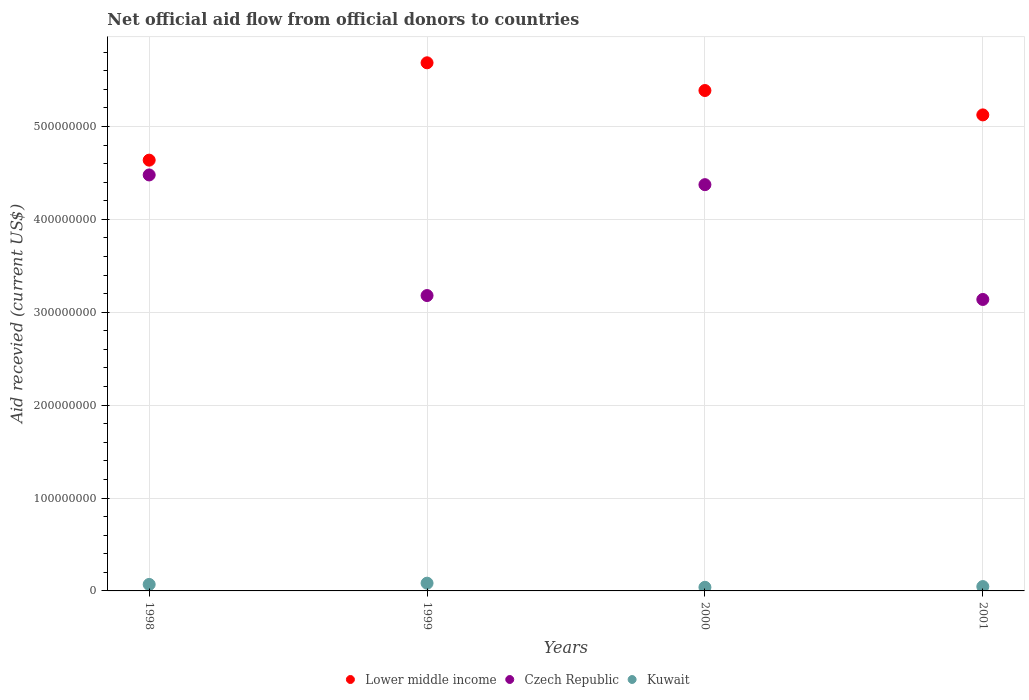How many different coloured dotlines are there?
Your answer should be very brief. 3. What is the total aid received in Czech Republic in 2001?
Make the answer very short. 3.14e+08. Across all years, what is the maximum total aid received in Lower middle income?
Provide a short and direct response. 5.69e+08. Across all years, what is the minimum total aid received in Kuwait?
Give a very brief answer. 3.89e+06. In which year was the total aid received in Kuwait maximum?
Keep it short and to the point. 1999. In which year was the total aid received in Lower middle income minimum?
Your response must be concise. 1998. What is the total total aid received in Czech Republic in the graph?
Your response must be concise. 1.52e+09. What is the difference between the total aid received in Kuwait in 1998 and that in 2001?
Keep it short and to the point. 2.30e+06. What is the difference between the total aid received in Lower middle income in 1999 and the total aid received in Kuwait in 2000?
Keep it short and to the point. 5.65e+08. What is the average total aid received in Lower middle income per year?
Your answer should be compact. 5.21e+08. In the year 1999, what is the difference between the total aid received in Czech Republic and total aid received in Lower middle income?
Offer a very short reply. -2.51e+08. What is the ratio of the total aid received in Czech Republic in 1998 to that in 1999?
Provide a short and direct response. 1.41. Is the total aid received in Czech Republic in 1999 less than that in 2001?
Your answer should be compact. No. Is the difference between the total aid received in Czech Republic in 1999 and 2001 greater than the difference between the total aid received in Lower middle income in 1999 and 2001?
Provide a short and direct response. No. What is the difference between the highest and the second highest total aid received in Kuwait?
Your answer should be compact. 1.34e+06. What is the difference between the highest and the lowest total aid received in Czech Republic?
Make the answer very short. 1.34e+08. In how many years, is the total aid received in Lower middle income greater than the average total aid received in Lower middle income taken over all years?
Give a very brief answer. 2. Is the sum of the total aid received in Czech Republic in 1998 and 2001 greater than the maximum total aid received in Lower middle income across all years?
Your answer should be very brief. Yes. Is the total aid received in Lower middle income strictly less than the total aid received in Kuwait over the years?
Ensure brevity in your answer.  No. How many dotlines are there?
Offer a terse response. 3. What is the difference between two consecutive major ticks on the Y-axis?
Make the answer very short. 1.00e+08. What is the title of the graph?
Provide a succinct answer. Net official aid flow from official donors to countries. What is the label or title of the Y-axis?
Offer a very short reply. Aid recevied (current US$). What is the Aid recevied (current US$) of Lower middle income in 1998?
Your answer should be very brief. 4.64e+08. What is the Aid recevied (current US$) in Czech Republic in 1998?
Offer a terse response. 4.48e+08. What is the Aid recevied (current US$) of Kuwait in 1998?
Your answer should be compact. 6.99e+06. What is the Aid recevied (current US$) of Lower middle income in 1999?
Make the answer very short. 5.69e+08. What is the Aid recevied (current US$) of Czech Republic in 1999?
Offer a terse response. 3.18e+08. What is the Aid recevied (current US$) of Kuwait in 1999?
Ensure brevity in your answer.  8.33e+06. What is the Aid recevied (current US$) in Lower middle income in 2000?
Your answer should be compact. 5.39e+08. What is the Aid recevied (current US$) of Czech Republic in 2000?
Offer a terse response. 4.37e+08. What is the Aid recevied (current US$) in Kuwait in 2000?
Your answer should be very brief. 3.89e+06. What is the Aid recevied (current US$) of Lower middle income in 2001?
Your answer should be very brief. 5.12e+08. What is the Aid recevied (current US$) in Czech Republic in 2001?
Ensure brevity in your answer.  3.14e+08. What is the Aid recevied (current US$) in Kuwait in 2001?
Keep it short and to the point. 4.69e+06. Across all years, what is the maximum Aid recevied (current US$) of Lower middle income?
Keep it short and to the point. 5.69e+08. Across all years, what is the maximum Aid recevied (current US$) in Czech Republic?
Give a very brief answer. 4.48e+08. Across all years, what is the maximum Aid recevied (current US$) of Kuwait?
Ensure brevity in your answer.  8.33e+06. Across all years, what is the minimum Aid recevied (current US$) of Lower middle income?
Make the answer very short. 4.64e+08. Across all years, what is the minimum Aid recevied (current US$) of Czech Republic?
Offer a terse response. 3.14e+08. Across all years, what is the minimum Aid recevied (current US$) in Kuwait?
Your response must be concise. 3.89e+06. What is the total Aid recevied (current US$) in Lower middle income in the graph?
Your answer should be compact. 2.08e+09. What is the total Aid recevied (current US$) in Czech Republic in the graph?
Give a very brief answer. 1.52e+09. What is the total Aid recevied (current US$) of Kuwait in the graph?
Give a very brief answer. 2.39e+07. What is the difference between the Aid recevied (current US$) in Lower middle income in 1998 and that in 1999?
Ensure brevity in your answer.  -1.05e+08. What is the difference between the Aid recevied (current US$) in Czech Republic in 1998 and that in 1999?
Provide a short and direct response. 1.30e+08. What is the difference between the Aid recevied (current US$) in Kuwait in 1998 and that in 1999?
Offer a terse response. -1.34e+06. What is the difference between the Aid recevied (current US$) in Lower middle income in 1998 and that in 2000?
Ensure brevity in your answer.  -7.50e+07. What is the difference between the Aid recevied (current US$) in Czech Republic in 1998 and that in 2000?
Offer a very short reply. 1.05e+07. What is the difference between the Aid recevied (current US$) of Kuwait in 1998 and that in 2000?
Your response must be concise. 3.10e+06. What is the difference between the Aid recevied (current US$) in Lower middle income in 1998 and that in 2001?
Offer a very short reply. -4.87e+07. What is the difference between the Aid recevied (current US$) in Czech Republic in 1998 and that in 2001?
Your response must be concise. 1.34e+08. What is the difference between the Aid recevied (current US$) of Kuwait in 1998 and that in 2001?
Your response must be concise. 2.30e+06. What is the difference between the Aid recevied (current US$) of Lower middle income in 1999 and that in 2000?
Offer a very short reply. 2.98e+07. What is the difference between the Aid recevied (current US$) in Czech Republic in 1999 and that in 2000?
Make the answer very short. -1.19e+08. What is the difference between the Aid recevied (current US$) of Kuwait in 1999 and that in 2000?
Keep it short and to the point. 4.44e+06. What is the difference between the Aid recevied (current US$) in Lower middle income in 1999 and that in 2001?
Give a very brief answer. 5.61e+07. What is the difference between the Aid recevied (current US$) of Czech Republic in 1999 and that in 2001?
Make the answer very short. 4.21e+06. What is the difference between the Aid recevied (current US$) in Kuwait in 1999 and that in 2001?
Provide a short and direct response. 3.64e+06. What is the difference between the Aid recevied (current US$) in Lower middle income in 2000 and that in 2001?
Ensure brevity in your answer.  2.62e+07. What is the difference between the Aid recevied (current US$) of Czech Republic in 2000 and that in 2001?
Offer a terse response. 1.24e+08. What is the difference between the Aid recevied (current US$) in Kuwait in 2000 and that in 2001?
Offer a very short reply. -8.00e+05. What is the difference between the Aid recevied (current US$) of Lower middle income in 1998 and the Aid recevied (current US$) of Czech Republic in 1999?
Your answer should be compact. 1.46e+08. What is the difference between the Aid recevied (current US$) of Lower middle income in 1998 and the Aid recevied (current US$) of Kuwait in 1999?
Ensure brevity in your answer.  4.55e+08. What is the difference between the Aid recevied (current US$) of Czech Republic in 1998 and the Aid recevied (current US$) of Kuwait in 1999?
Your answer should be compact. 4.40e+08. What is the difference between the Aid recevied (current US$) in Lower middle income in 1998 and the Aid recevied (current US$) in Czech Republic in 2000?
Give a very brief answer. 2.64e+07. What is the difference between the Aid recevied (current US$) in Lower middle income in 1998 and the Aid recevied (current US$) in Kuwait in 2000?
Your answer should be compact. 4.60e+08. What is the difference between the Aid recevied (current US$) of Czech Republic in 1998 and the Aid recevied (current US$) of Kuwait in 2000?
Make the answer very short. 4.44e+08. What is the difference between the Aid recevied (current US$) of Lower middle income in 1998 and the Aid recevied (current US$) of Czech Republic in 2001?
Your answer should be very brief. 1.50e+08. What is the difference between the Aid recevied (current US$) in Lower middle income in 1998 and the Aid recevied (current US$) in Kuwait in 2001?
Offer a terse response. 4.59e+08. What is the difference between the Aid recevied (current US$) of Czech Republic in 1998 and the Aid recevied (current US$) of Kuwait in 2001?
Provide a succinct answer. 4.43e+08. What is the difference between the Aid recevied (current US$) of Lower middle income in 1999 and the Aid recevied (current US$) of Czech Republic in 2000?
Offer a terse response. 1.31e+08. What is the difference between the Aid recevied (current US$) of Lower middle income in 1999 and the Aid recevied (current US$) of Kuwait in 2000?
Keep it short and to the point. 5.65e+08. What is the difference between the Aid recevied (current US$) in Czech Republic in 1999 and the Aid recevied (current US$) in Kuwait in 2000?
Make the answer very short. 3.14e+08. What is the difference between the Aid recevied (current US$) in Lower middle income in 1999 and the Aid recevied (current US$) in Czech Republic in 2001?
Offer a terse response. 2.55e+08. What is the difference between the Aid recevied (current US$) in Lower middle income in 1999 and the Aid recevied (current US$) in Kuwait in 2001?
Keep it short and to the point. 5.64e+08. What is the difference between the Aid recevied (current US$) of Czech Republic in 1999 and the Aid recevied (current US$) of Kuwait in 2001?
Offer a terse response. 3.13e+08. What is the difference between the Aid recevied (current US$) in Lower middle income in 2000 and the Aid recevied (current US$) in Czech Republic in 2001?
Ensure brevity in your answer.  2.25e+08. What is the difference between the Aid recevied (current US$) in Lower middle income in 2000 and the Aid recevied (current US$) in Kuwait in 2001?
Give a very brief answer. 5.34e+08. What is the difference between the Aid recevied (current US$) in Czech Republic in 2000 and the Aid recevied (current US$) in Kuwait in 2001?
Offer a very short reply. 4.33e+08. What is the average Aid recevied (current US$) in Lower middle income per year?
Make the answer very short. 5.21e+08. What is the average Aid recevied (current US$) in Czech Republic per year?
Your response must be concise. 3.79e+08. What is the average Aid recevied (current US$) in Kuwait per year?
Offer a terse response. 5.98e+06. In the year 1998, what is the difference between the Aid recevied (current US$) of Lower middle income and Aid recevied (current US$) of Czech Republic?
Your response must be concise. 1.59e+07. In the year 1998, what is the difference between the Aid recevied (current US$) of Lower middle income and Aid recevied (current US$) of Kuwait?
Give a very brief answer. 4.57e+08. In the year 1998, what is the difference between the Aid recevied (current US$) in Czech Republic and Aid recevied (current US$) in Kuwait?
Your answer should be compact. 4.41e+08. In the year 1999, what is the difference between the Aid recevied (current US$) of Lower middle income and Aid recevied (current US$) of Czech Republic?
Give a very brief answer. 2.51e+08. In the year 1999, what is the difference between the Aid recevied (current US$) of Lower middle income and Aid recevied (current US$) of Kuwait?
Make the answer very short. 5.60e+08. In the year 1999, what is the difference between the Aid recevied (current US$) of Czech Republic and Aid recevied (current US$) of Kuwait?
Your response must be concise. 3.10e+08. In the year 2000, what is the difference between the Aid recevied (current US$) in Lower middle income and Aid recevied (current US$) in Czech Republic?
Provide a succinct answer. 1.01e+08. In the year 2000, what is the difference between the Aid recevied (current US$) of Lower middle income and Aid recevied (current US$) of Kuwait?
Provide a succinct answer. 5.35e+08. In the year 2000, what is the difference between the Aid recevied (current US$) of Czech Republic and Aid recevied (current US$) of Kuwait?
Make the answer very short. 4.33e+08. In the year 2001, what is the difference between the Aid recevied (current US$) in Lower middle income and Aid recevied (current US$) in Czech Republic?
Your answer should be very brief. 1.99e+08. In the year 2001, what is the difference between the Aid recevied (current US$) of Lower middle income and Aid recevied (current US$) of Kuwait?
Offer a very short reply. 5.08e+08. In the year 2001, what is the difference between the Aid recevied (current US$) in Czech Republic and Aid recevied (current US$) in Kuwait?
Your response must be concise. 3.09e+08. What is the ratio of the Aid recevied (current US$) in Lower middle income in 1998 to that in 1999?
Provide a short and direct response. 0.82. What is the ratio of the Aid recevied (current US$) in Czech Republic in 1998 to that in 1999?
Keep it short and to the point. 1.41. What is the ratio of the Aid recevied (current US$) in Kuwait in 1998 to that in 1999?
Your response must be concise. 0.84. What is the ratio of the Aid recevied (current US$) in Lower middle income in 1998 to that in 2000?
Ensure brevity in your answer.  0.86. What is the ratio of the Aid recevied (current US$) of Czech Republic in 1998 to that in 2000?
Your answer should be very brief. 1.02. What is the ratio of the Aid recevied (current US$) in Kuwait in 1998 to that in 2000?
Offer a very short reply. 1.8. What is the ratio of the Aid recevied (current US$) of Lower middle income in 1998 to that in 2001?
Ensure brevity in your answer.  0.91. What is the ratio of the Aid recevied (current US$) of Czech Republic in 1998 to that in 2001?
Provide a short and direct response. 1.43. What is the ratio of the Aid recevied (current US$) in Kuwait in 1998 to that in 2001?
Provide a short and direct response. 1.49. What is the ratio of the Aid recevied (current US$) of Lower middle income in 1999 to that in 2000?
Your response must be concise. 1.06. What is the ratio of the Aid recevied (current US$) of Czech Republic in 1999 to that in 2000?
Keep it short and to the point. 0.73. What is the ratio of the Aid recevied (current US$) in Kuwait in 1999 to that in 2000?
Provide a short and direct response. 2.14. What is the ratio of the Aid recevied (current US$) of Lower middle income in 1999 to that in 2001?
Offer a terse response. 1.11. What is the ratio of the Aid recevied (current US$) of Czech Republic in 1999 to that in 2001?
Provide a short and direct response. 1.01. What is the ratio of the Aid recevied (current US$) of Kuwait in 1999 to that in 2001?
Keep it short and to the point. 1.78. What is the ratio of the Aid recevied (current US$) in Lower middle income in 2000 to that in 2001?
Ensure brevity in your answer.  1.05. What is the ratio of the Aid recevied (current US$) in Czech Republic in 2000 to that in 2001?
Provide a succinct answer. 1.39. What is the ratio of the Aid recevied (current US$) of Kuwait in 2000 to that in 2001?
Provide a succinct answer. 0.83. What is the difference between the highest and the second highest Aid recevied (current US$) of Lower middle income?
Provide a succinct answer. 2.98e+07. What is the difference between the highest and the second highest Aid recevied (current US$) of Czech Republic?
Your response must be concise. 1.05e+07. What is the difference between the highest and the second highest Aid recevied (current US$) in Kuwait?
Give a very brief answer. 1.34e+06. What is the difference between the highest and the lowest Aid recevied (current US$) of Lower middle income?
Your response must be concise. 1.05e+08. What is the difference between the highest and the lowest Aid recevied (current US$) in Czech Republic?
Give a very brief answer. 1.34e+08. What is the difference between the highest and the lowest Aid recevied (current US$) in Kuwait?
Your answer should be very brief. 4.44e+06. 